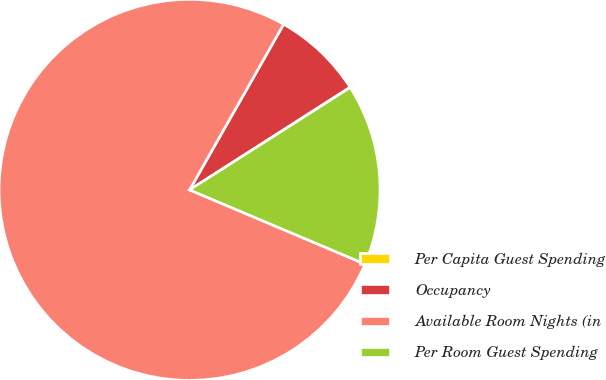<chart> <loc_0><loc_0><loc_500><loc_500><pie_chart><fcel>Per Capita Guest Spending<fcel>Occupancy<fcel>Available Room Nights (in<fcel>Per Room Guest Spending<nl><fcel>0.03%<fcel>7.72%<fcel>76.85%<fcel>15.4%<nl></chart> 